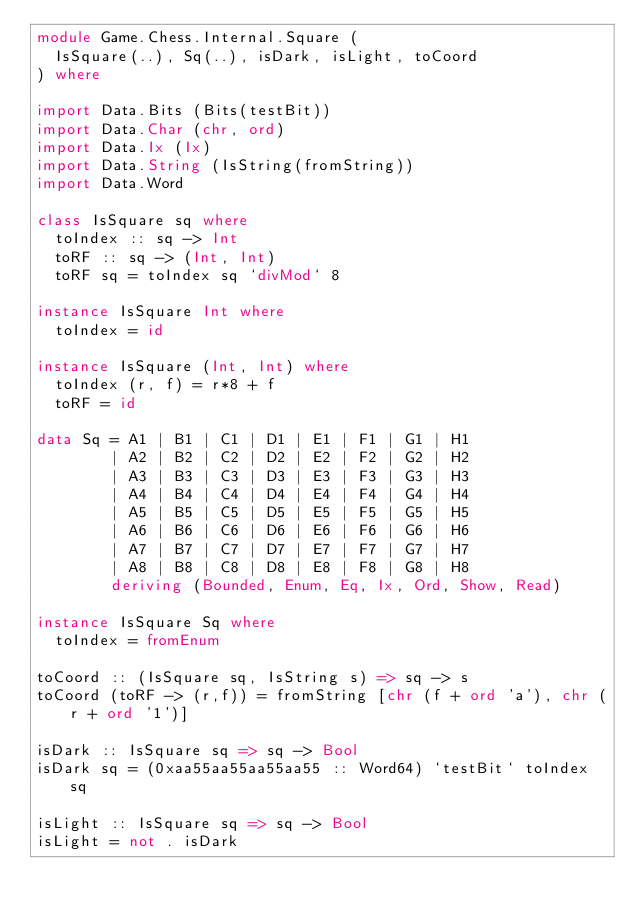<code> <loc_0><loc_0><loc_500><loc_500><_Haskell_>module Game.Chess.Internal.Square (
  IsSquare(..), Sq(..), isDark, isLight, toCoord
) where

import Data.Bits (Bits(testBit))
import Data.Char (chr, ord)
import Data.Ix (Ix)
import Data.String (IsString(fromString))
import Data.Word

class IsSquare sq where
  toIndex :: sq -> Int
  toRF :: sq -> (Int, Int)
  toRF sq = toIndex sq `divMod` 8

instance IsSquare Int where
  toIndex = id

instance IsSquare (Int, Int) where
  toIndex (r, f) = r*8 + f
  toRF = id

data Sq = A1 | B1 | C1 | D1 | E1 | F1 | G1 | H1
        | A2 | B2 | C2 | D2 | E2 | F2 | G2 | H2
        | A3 | B3 | C3 | D3 | E3 | F3 | G3 | H3
        | A4 | B4 | C4 | D4 | E4 | F4 | G4 | H4
        | A5 | B5 | C5 | D5 | E5 | F5 | G5 | H5
        | A6 | B6 | C6 | D6 | E6 | F6 | G6 | H6
        | A7 | B7 | C7 | D7 | E7 | F7 | G7 | H7
        | A8 | B8 | C8 | D8 | E8 | F8 | G8 | H8
        deriving (Bounded, Enum, Eq, Ix, Ord, Show, Read)

instance IsSquare Sq where
  toIndex = fromEnum

toCoord :: (IsSquare sq, IsString s) => sq -> s
toCoord (toRF -> (r,f)) = fromString [chr (f + ord 'a'), chr (r + ord '1')]

isDark :: IsSquare sq => sq -> Bool
isDark sq = (0xaa55aa55aa55aa55 :: Word64) `testBit` toIndex sq

isLight :: IsSquare sq => sq -> Bool
isLight = not . isDark
</code> 